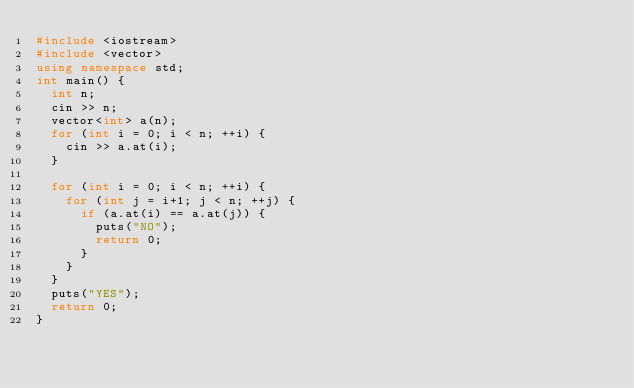Convert code to text. <code><loc_0><loc_0><loc_500><loc_500><_C++_>#include <iostream>
#include <vector>
using namespace std;
int main() {
  int n;
  cin >> n;
  vector<int> a(n);
  for (int i = 0; i < n; ++i) {
    cin >> a.at(i);
  }
  
  for (int i = 0; i < n; ++i) {
    for (int j = i+1; j < n; ++j) {
      if (a.at(i) == a.at(j)) {
        puts("NO");
        return 0;
      }
    }
  }
  puts("YES");
  return 0;
}</code> 